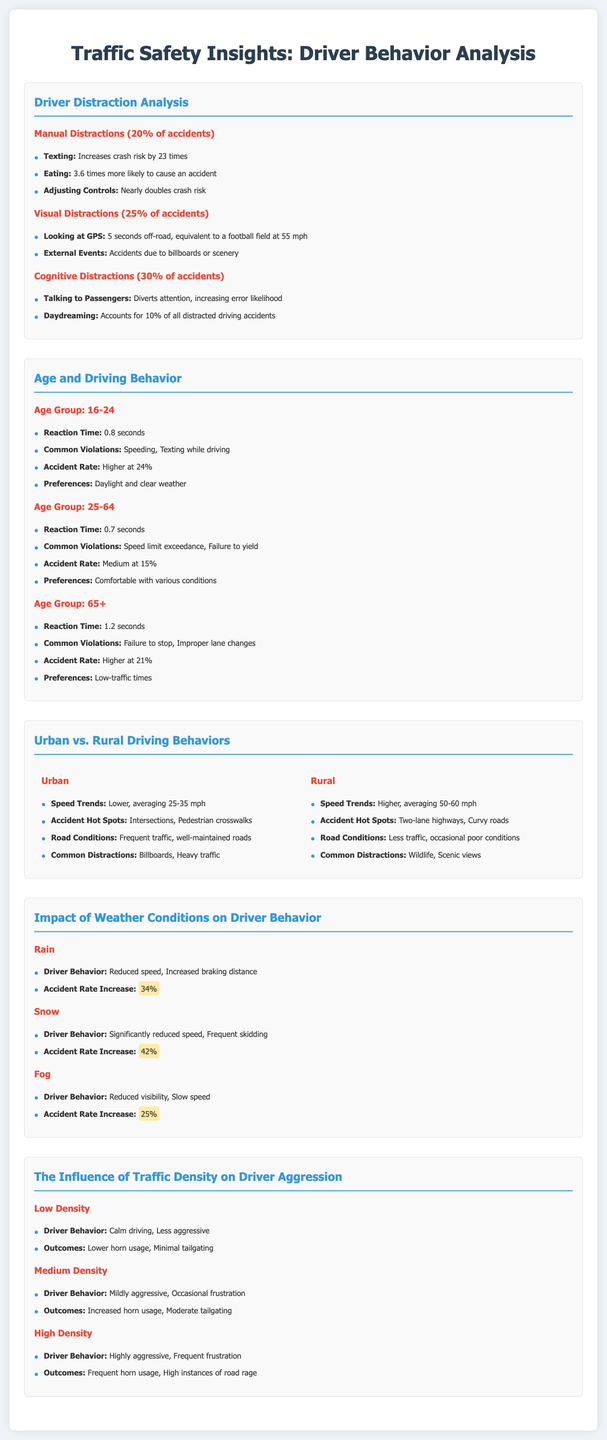what is the accident increase risk for texting? The document states that texting increases crash risk by 23 times.
Answer: 23 times which age group has the highest accident rate? The highest accident rate at 24% is associated with the age group 16-24.
Answer: 16-24 what is the common violation for drivers aged 65 and older? The common violations for this age group include failure to stop and improper lane changes.
Answer: Failure to stop, improper lane changes how does fog affect accident rates according to the document? The document states that fog increases accident rates by 25%.
Answer: 25% what are common distractions for urban drivers? Common distractions for urban drivers include billboards and heavy traffic.
Answer: Billboards, heavy traffic what is the percentage increase in accident rates during snowy conditions? The accident rate increase during snowy conditions is stated as 42%.
Answer: 42% how long is the off-road distraction when looking at GPS? Looking at GPS results in 5 seconds off-road, which is equivalent to a football field at 55 mph.
Answer: 5 seconds which driving condition do young drivers prefer? Young drivers prefer daylight and clear weather conditions.
Answer: Daylight and clear weather what driver behavior is observed in high traffic density? In high traffic density, drivers display highly aggressive behavior and frequent frustration.
Answer: Highly aggressive, frequent frustration 